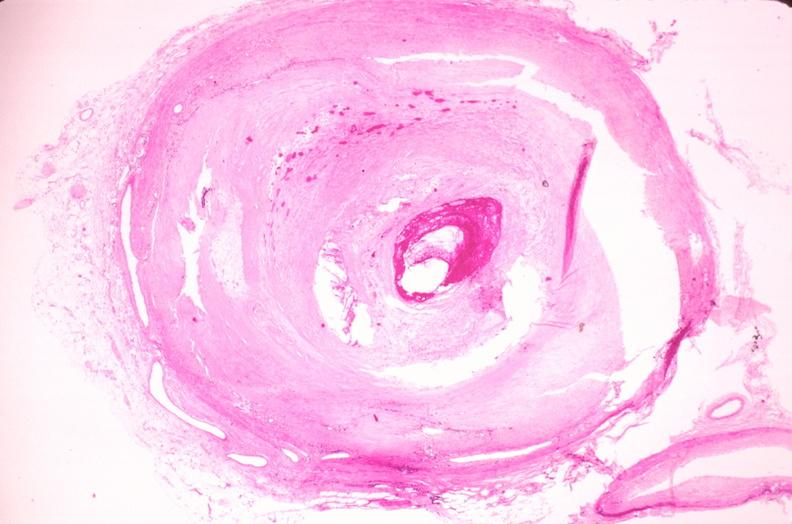where is this in?
Answer the question using a single word or phrase. In vasculature 